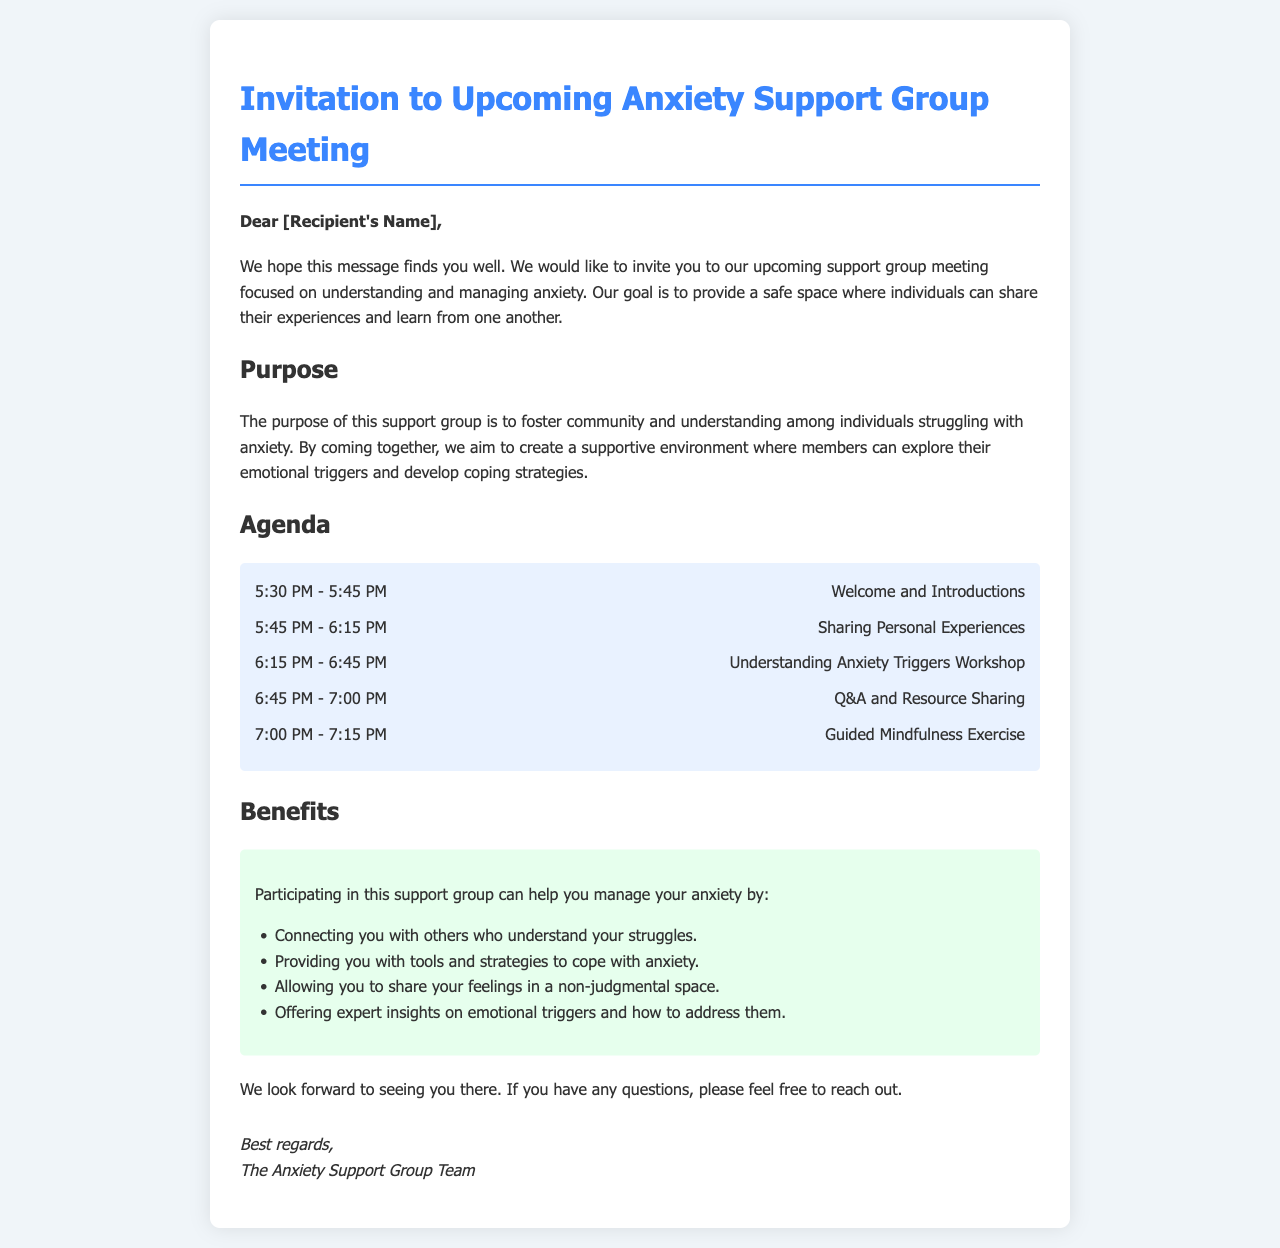What is the title of the document? The title of the document is specified in the head section of the HTML code.
Answer: Invitation to Upcoming Anxiety Support Group Meeting What is the purpose of the support group? The document states that the purpose is to foster community and understanding among individuals struggling with anxiety.
Answer: Foster community and understanding When does the meeting start? The meeting starts at the time mentioned in the agenda section of the document.
Answer: 5:30 PM How many agenda items are listed? The document provides a specific count of the agenda items listed in the agenda section.
Answer: Five What is the last agenda item? The document lists each agenda item along with its time; the last one is at the end of this list.
Answer: Guided Mindfulness Exercise What benefit is specifically mentioned regarding sharing feelings? The document outlines benefits with specific phrases that each list begins with.
Answer: Non-judgmental space Which new skill will be focused on during the meeting? The document refers to a specific workshop focused on a particular aspect of anxiety management.
Answer: Understanding Anxiety Triggers Workshop Who is organizing the meeting? The last section of the document identifies the organizing entity responsible for the meeting.
Answer: The Anxiety Support Group Team What type of exercise will be conducted at the end? The document specifies the nature of the last agenda item as a type of practice.
Answer: Mindfulness Exercise 